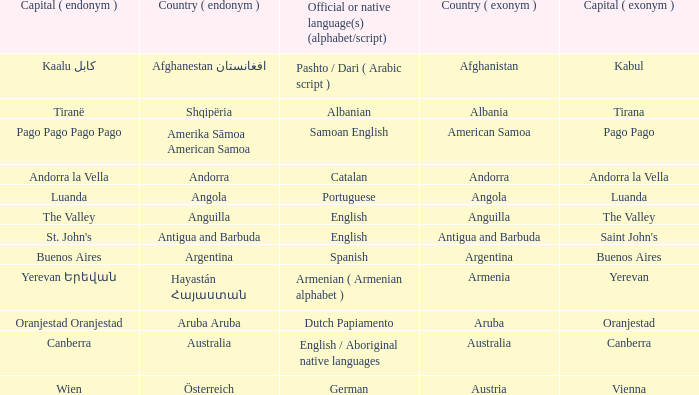What is the local name given to the city of Canberra? Canberra. 